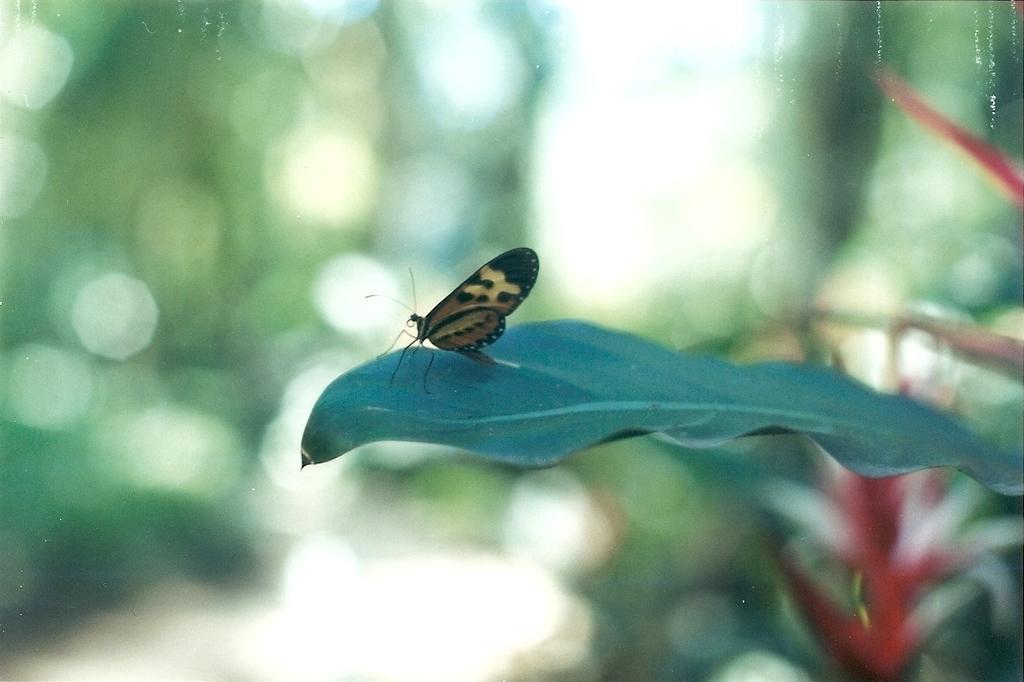Can you describe this image briefly? In this image we can see a butterfly on the leaf and there is a flower. There is a blur background. 